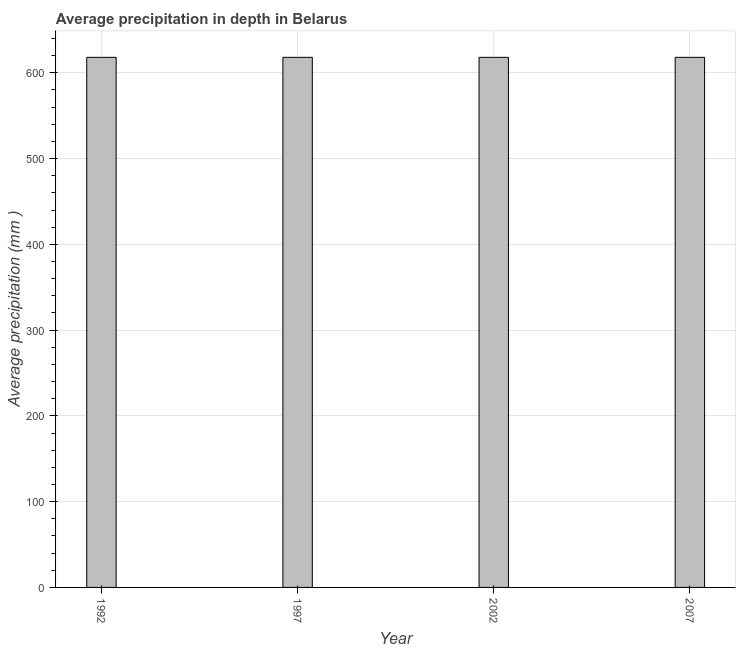Does the graph contain any zero values?
Give a very brief answer. No. What is the title of the graph?
Ensure brevity in your answer.  Average precipitation in depth in Belarus. What is the label or title of the X-axis?
Your answer should be compact. Year. What is the label or title of the Y-axis?
Offer a very short reply. Average precipitation (mm ). What is the average precipitation in depth in 1992?
Make the answer very short. 618. Across all years, what is the maximum average precipitation in depth?
Your answer should be very brief. 618. Across all years, what is the minimum average precipitation in depth?
Provide a succinct answer. 618. In which year was the average precipitation in depth minimum?
Give a very brief answer. 1992. What is the sum of the average precipitation in depth?
Give a very brief answer. 2472. What is the difference between the average precipitation in depth in 1992 and 2002?
Your answer should be very brief. 0. What is the average average precipitation in depth per year?
Offer a terse response. 618. What is the median average precipitation in depth?
Offer a very short reply. 618. Is the difference between the average precipitation in depth in 2002 and 2007 greater than the difference between any two years?
Give a very brief answer. Yes. What is the difference between the highest and the second highest average precipitation in depth?
Your response must be concise. 0. Is the sum of the average precipitation in depth in 1992 and 1997 greater than the maximum average precipitation in depth across all years?
Your response must be concise. Yes. In how many years, is the average precipitation in depth greater than the average average precipitation in depth taken over all years?
Provide a succinct answer. 0. How many bars are there?
Make the answer very short. 4. Are all the bars in the graph horizontal?
Offer a terse response. No. How many years are there in the graph?
Ensure brevity in your answer.  4. What is the difference between two consecutive major ticks on the Y-axis?
Give a very brief answer. 100. What is the Average precipitation (mm ) in 1992?
Your answer should be compact. 618. What is the Average precipitation (mm ) in 1997?
Provide a succinct answer. 618. What is the Average precipitation (mm ) in 2002?
Your response must be concise. 618. What is the Average precipitation (mm ) of 2007?
Offer a very short reply. 618. What is the difference between the Average precipitation (mm ) in 1992 and 2002?
Your response must be concise. 0. What is the difference between the Average precipitation (mm ) in 1997 and 2007?
Keep it short and to the point. 0. What is the difference between the Average precipitation (mm ) in 2002 and 2007?
Provide a succinct answer. 0. What is the ratio of the Average precipitation (mm ) in 2002 to that in 2007?
Give a very brief answer. 1. 